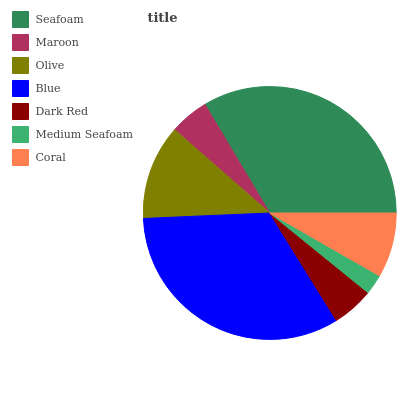Is Medium Seafoam the minimum?
Answer yes or no. Yes. Is Seafoam the maximum?
Answer yes or no. Yes. Is Maroon the minimum?
Answer yes or no. No. Is Maroon the maximum?
Answer yes or no. No. Is Seafoam greater than Maroon?
Answer yes or no. Yes. Is Maroon less than Seafoam?
Answer yes or no. Yes. Is Maroon greater than Seafoam?
Answer yes or no. No. Is Seafoam less than Maroon?
Answer yes or no. No. Is Coral the high median?
Answer yes or no. Yes. Is Coral the low median?
Answer yes or no. Yes. Is Olive the high median?
Answer yes or no. No. Is Olive the low median?
Answer yes or no. No. 